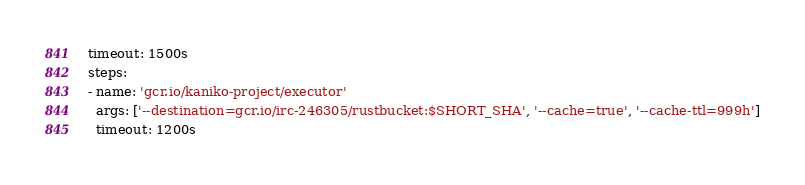<code> <loc_0><loc_0><loc_500><loc_500><_YAML_>timeout: 1500s
steps:
- name: 'gcr.io/kaniko-project/executor'
  args: ['--destination=gcr.io/irc-246305/rustbucket:$SHORT_SHA', '--cache=true', '--cache-ttl=999h']
  timeout: 1200s
</code> 